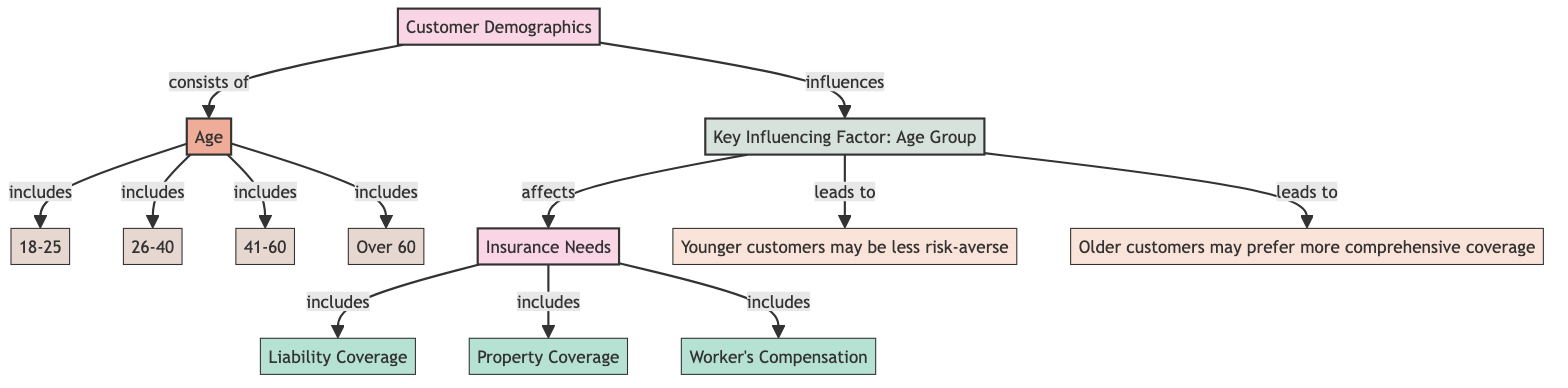What are the age groups listed under Customer Demographics? The diagram shows four specific age groups under Customer Demographics: 18-25, 26-40, 41-60, and Over 60. These groups represent the breakdown of customer demographics by age.
Answer: 18-25, 26-40, 41-60, Over 60 How many types of insurance needs are indicated in the diagram? The diagram identifies three types of insurance needs: Liability Coverage, Property Coverage, and Worker's Compensation. By counting these items, we see there are three distinct insurance types listed.
Answer: 3 What is the key influencing factor mentioned in the diagram? The diagram indicates that "Age Group" is the key influencing factor that connects Customer Demographics to Insurance Needs. It specifies that customer age influences their insurance requirements.
Answer: Age Group What do younger customers tend to prefer regarding risk? The diagram highlights that younger customers may be less risk-averse, suggesting they are more open to taking risks compared to older customers, who might seek different coverage options.
Answer: Less risk-averse How does the age group influence the need for insurance? The diagram shows a direct link from Age Group to Insurance Needs, indicating that customer age groups affect what kind of insurance coverage they may require. Therefore, age directly impacts insurance needs.
Answer: Affects insurance needs Which age group likely prefers more comprehensive coverage? According to the insights in the diagram, older customers are likely to prefer more comprehensive coverage, as they generally seek higher levels of protection in their insurance policies.
Answer: Older customers What insurance type is explicitly related to the age group's influence? The diagram illustrates that all insurance needs types (Liability Coverage, Property Coverage, and Worker's Compensation) are influenced by the age group of customers, tying these needs to the demographic model.
Answer: All insurance types How many subcategories are under Customer Demographics? The Customer Demographics category in the diagram contains one subcategory, which is Age. This identifies age as the primary factor within customer demographics.
Answer: 1 